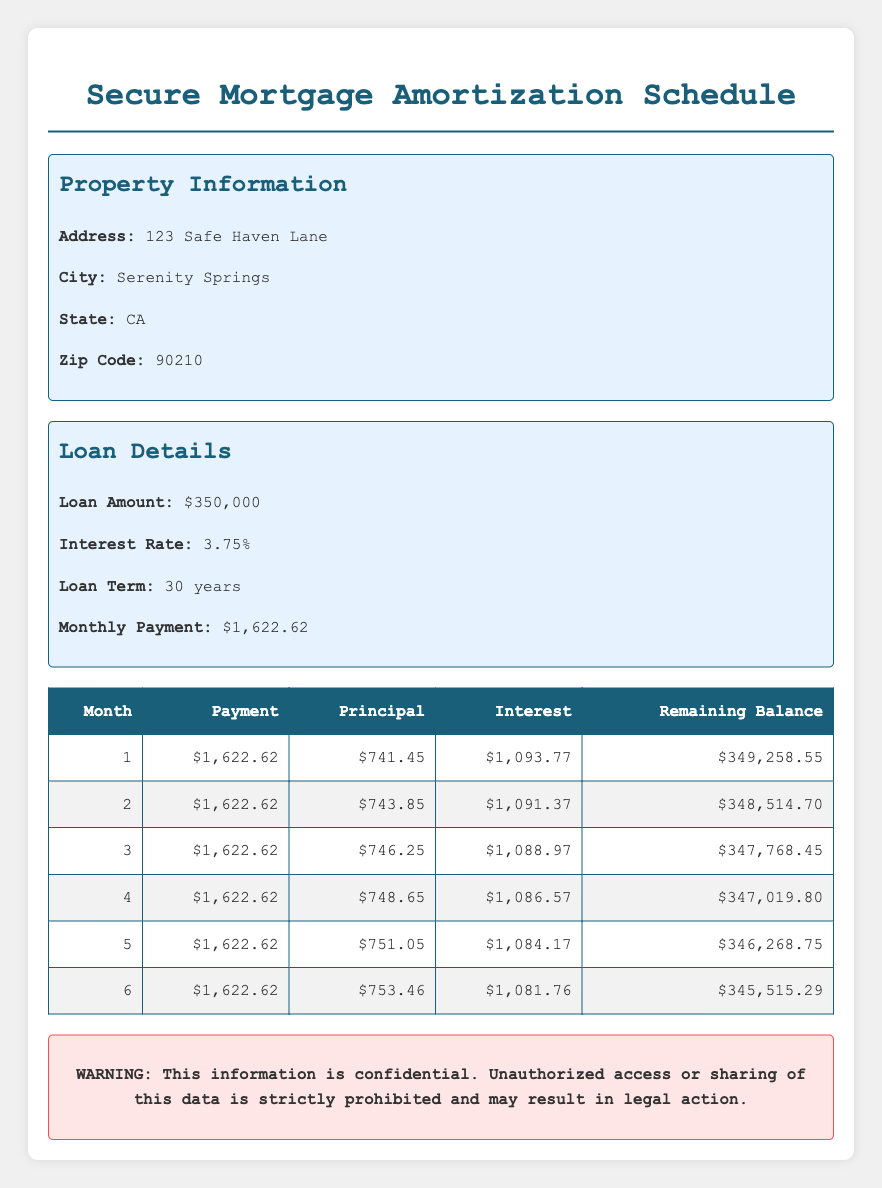What is the monthly payment for the mortgage? The monthly payment is mentioned directly in the loan details of the table. It states that the monthly payment is $1,622.62.
Answer: $1,622.62 What is the principal amount for the 3rd month? By referring to the amortization schedule, the principal amount for the 3rd month (March) is listed as $746.25.
Answer: $746.25 What is the total interest paid in the first six months? To find the total interest, sum the interest paid each month for the first six months: $1,093.77 + $1,091.37 + $1,088.97 + $1,086.57 + $1,084.17 + $1,081.76 = $6,526.01.
Answer: $6,526.01 Is the remaining balance after the 2nd month lower than $348,500? The remaining balance after the 2nd month is listed as $348,514.70, which is indeed lower than $348,500.
Answer: Yes What is the average principal paid over the first six months? To find the average principal, sum the principal amounts for the first six months: $741.45 + $743.85 + $746.25 + $748.65 + $751.05 + $753.46 = $3,984.71. Then divide by 6 (the number of months): $3,984.71 / 6 = $664.12.
Answer: $664.12 In which month is the principal payment the highest within the first six months? Looking at the principal amounts from the first six months, the values are $741.45, $743.85, $746.25, $748.65, $751.05, and $753.46. The highest is in the 6th month at $753.46.
Answer: 6 What is the difference between the interest paid in the 1st and 6th months? The interest paid in the 1st month is $1,093.77 and in the 6th month is $1,081.76. The difference is $1,093.77 - $1,081.76 = $12.01.
Answer: $12.01 How much of the loan has been paid down after the first six payments? The total principal paid after six months is calculated by summing the principal components: $741.45 + $743.85 + $746.25 + $748.65 + $751.05 + $753.46 = $3,984.71.
Answer: $3,984.71 